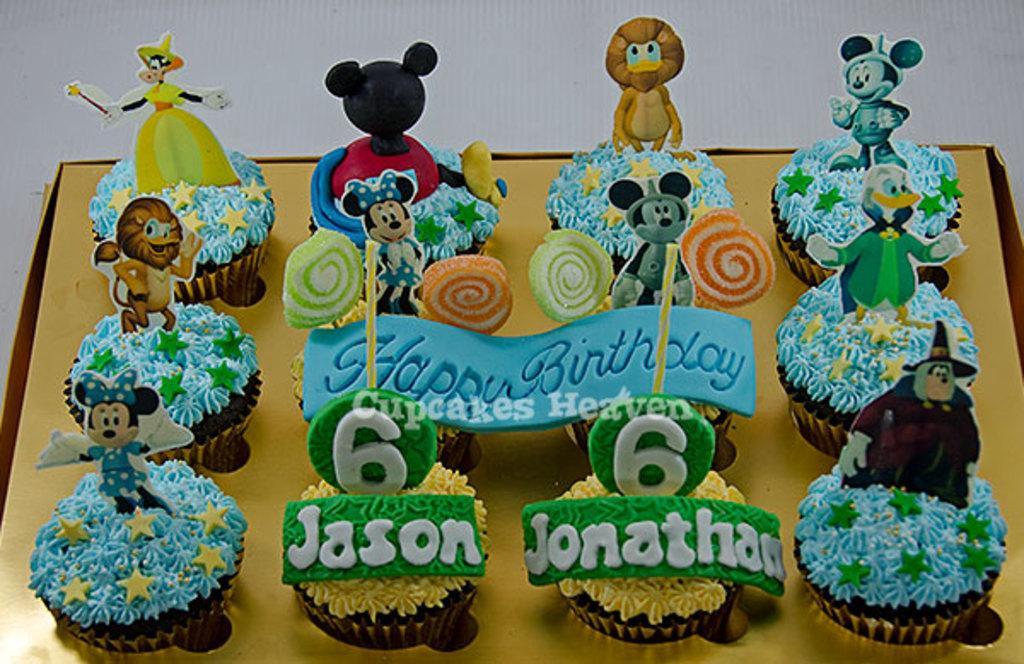Describe this image in one or two sentences. In this image there is a table with a box of cupcakes, candies and toys on it. 